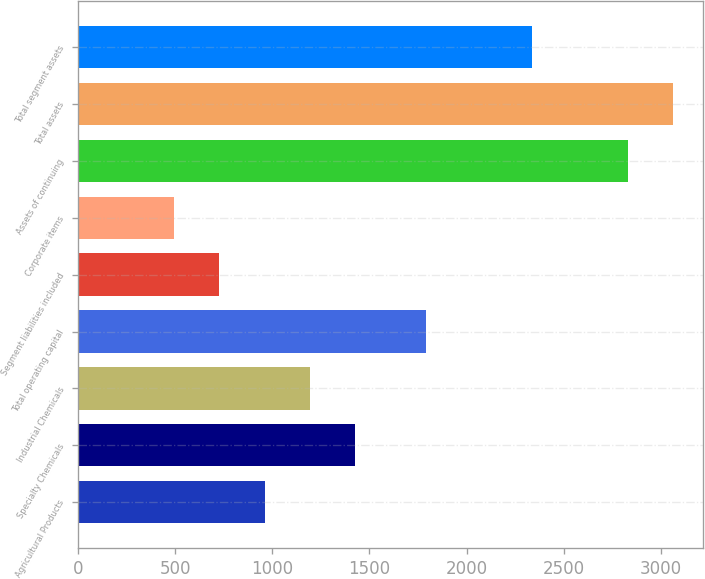Convert chart. <chart><loc_0><loc_0><loc_500><loc_500><bar_chart><fcel>Agricultural Products<fcel>Specialty Chemicals<fcel>Industrial Chemicals<fcel>Total operating capital<fcel>Segment liabilities included<fcel>Corporate items<fcel>Assets of continuing<fcel>Total assets<fcel>Total segment assets<nl><fcel>960.56<fcel>1427.62<fcel>1194.09<fcel>1790.5<fcel>727.03<fcel>493.5<fcel>2828.8<fcel>3062.33<fcel>2335.3<nl></chart> 